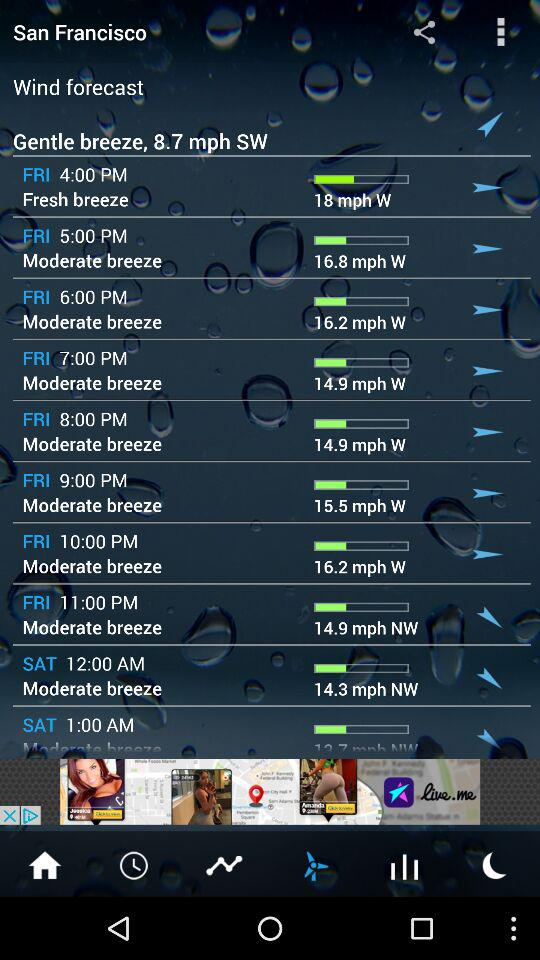What is the wind speed on Friday at 6 PM? The wind speed on Friday at 6 PM is 16.2 mph. 